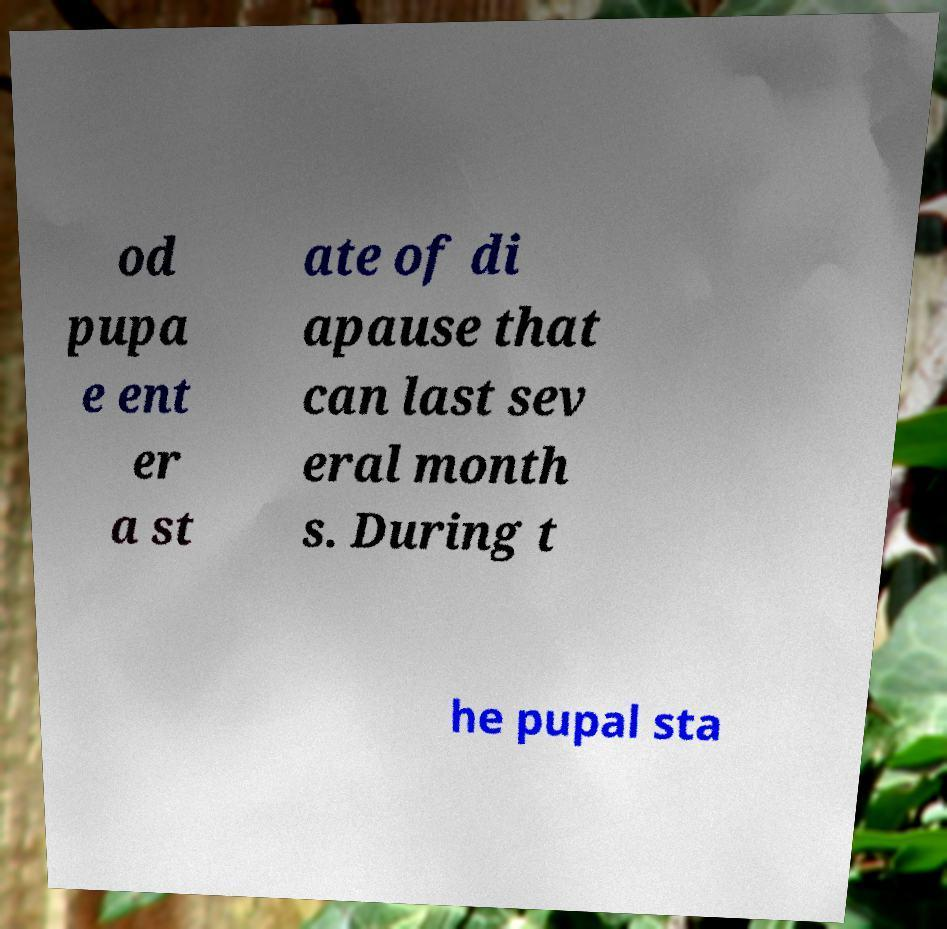Could you assist in decoding the text presented in this image and type it out clearly? od pupa e ent er a st ate of di apause that can last sev eral month s. During t he pupal sta 